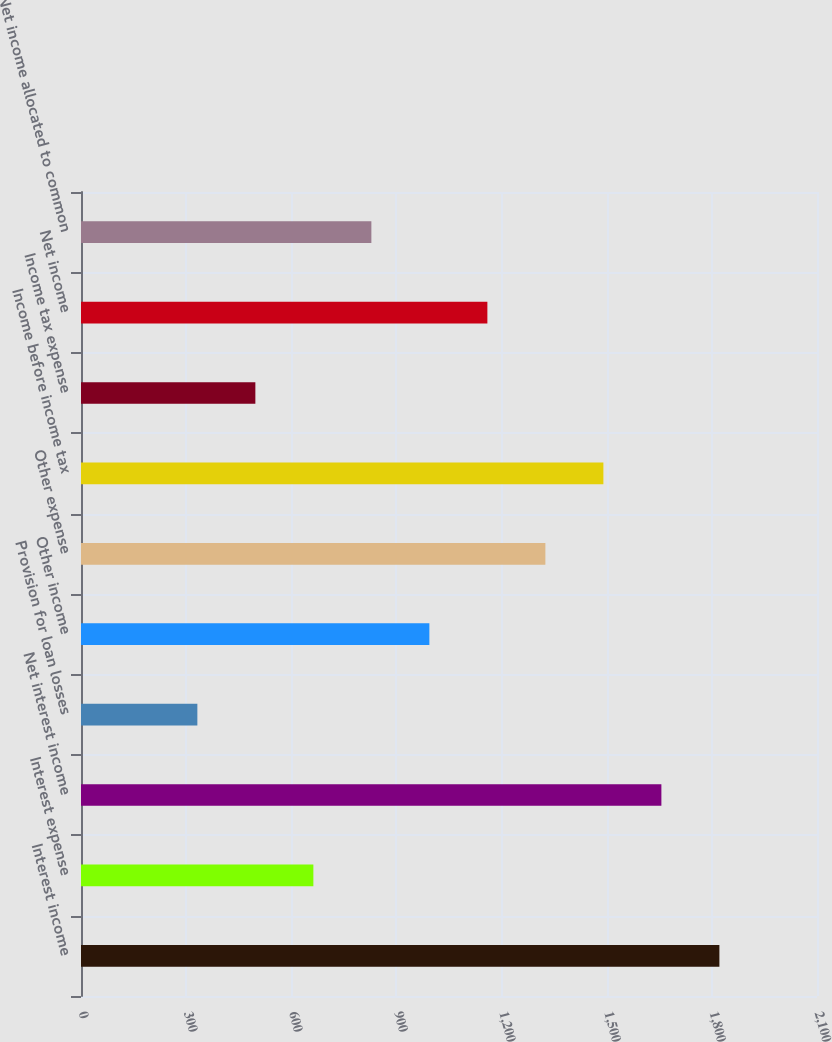<chart> <loc_0><loc_0><loc_500><loc_500><bar_chart><fcel>Interest income<fcel>Interest expense<fcel>Net interest income<fcel>Provision for loan losses<fcel>Other income<fcel>Other expense<fcel>Income before income tax<fcel>Income tax expense<fcel>Net income<fcel>Net income allocated to common<nl><fcel>1821.5<fcel>663<fcel>1656<fcel>332<fcel>994<fcel>1325<fcel>1490.5<fcel>497.5<fcel>1159.5<fcel>828.5<nl></chart> 